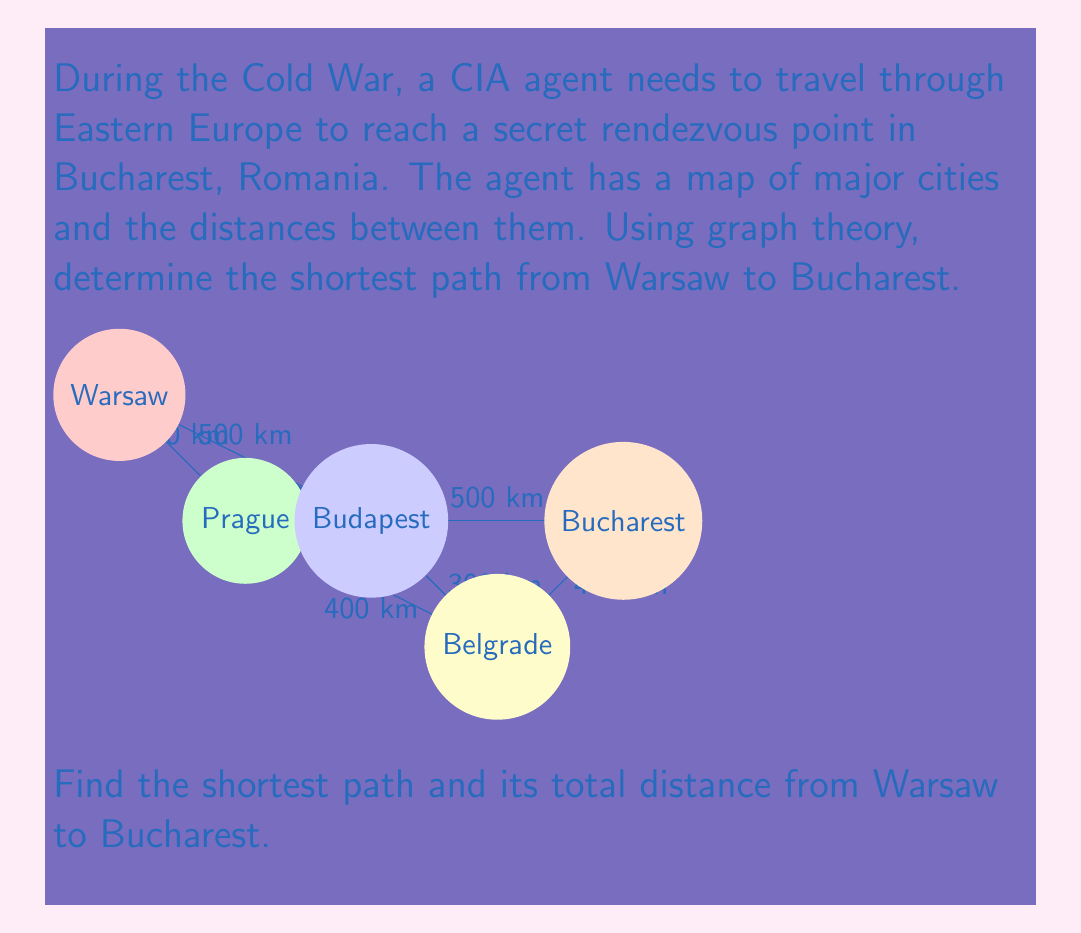Provide a solution to this math problem. To solve this problem, we'll use Dijkstra's algorithm, which is an efficient method for finding the shortest path in a weighted graph.

Step 1: Initialize the algorithm
- Set the distance to Warsaw as 0 and all other cities as infinity.
- Mark all nodes as unvisited.

Step 2: For the current node (starting with Warsaw), consider all unvisited neighbors and calculate their tentative distances.
- Warsaw to Prague: 400 km
- Warsaw to Budapest: 500 km

Step 3: Mark Warsaw as visited and move to the node with the smallest tentative distance (Prague).

Step 4: Update distances from Prague:
- Prague to Budapest: 400 + 450 = 850 km (not shorter than direct from Warsaw)
- Prague to Belgrade: 400 + 400 = 800 km

Step 5: Mark Prague as visited and move to Budapest (500 km from Warsaw).

Step 6: Update distances from Budapest:
- Budapest to Belgrade: 500 + 300 = 800 km
- Budapest to Bucharest: 500 + 500 = 1000 km

Step 7: Mark Budapest as visited and move to Belgrade (800 km from Warsaw through Prague).

Step 8: Update distance to Bucharest from Belgrade:
- Belgrade to Bucharest: 800 + 400 = 1200 km (not shorter than through Budapest)

Step 9: Mark Belgrade as visited. The shortest path to Bucharest is already found (1000 km through Budapest).

Therefore, the shortest path is Warsaw → Budapest → Bucharest, with a total distance of 1000 km.
Answer: Warsaw → Budapest → Bucharest, 1000 km 